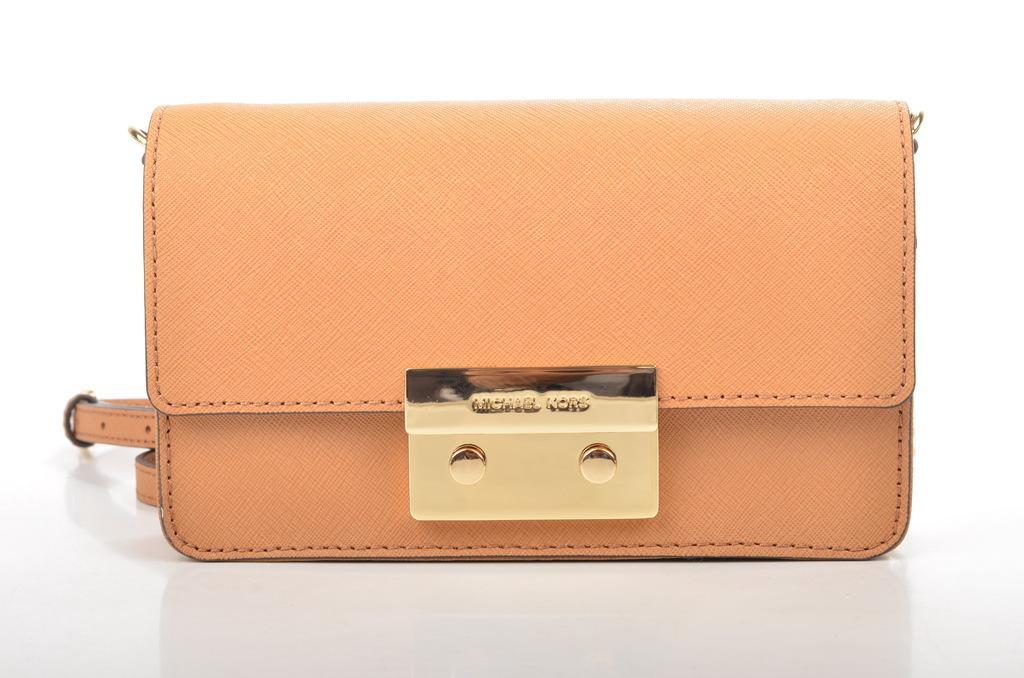Could you give a brief overview of what you see in this image? In the center we can see one hand bag,which is in yellow color. 